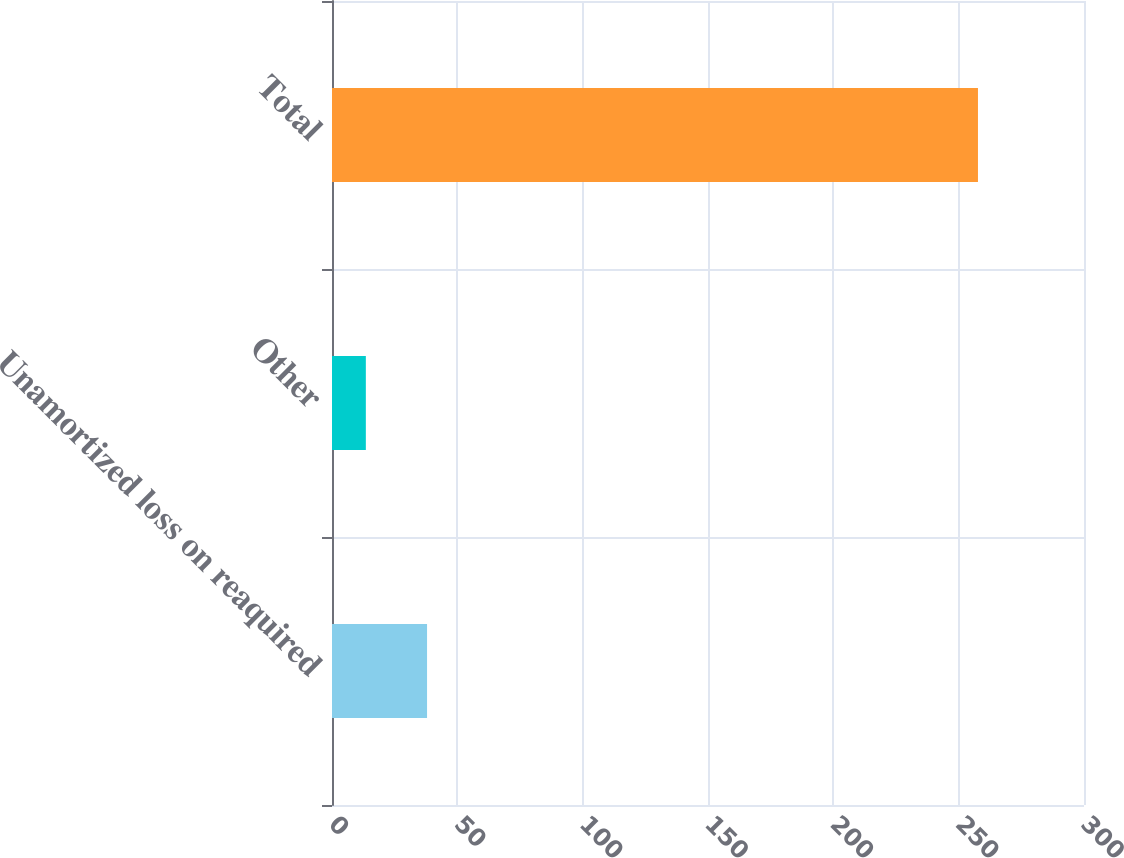Convert chart to OTSL. <chart><loc_0><loc_0><loc_500><loc_500><bar_chart><fcel>Unamortized loss on reaquired<fcel>Other<fcel>Total<nl><fcel>37.92<fcel>13.5<fcel>257.7<nl></chart> 